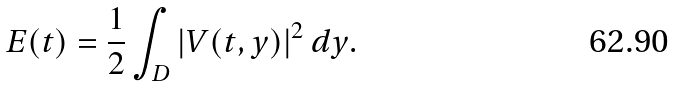<formula> <loc_0><loc_0><loc_500><loc_500>E ( t ) = \frac { 1 } { 2 } \int _ { D } | V ( t , y ) | ^ { 2 } \, d y .</formula> 